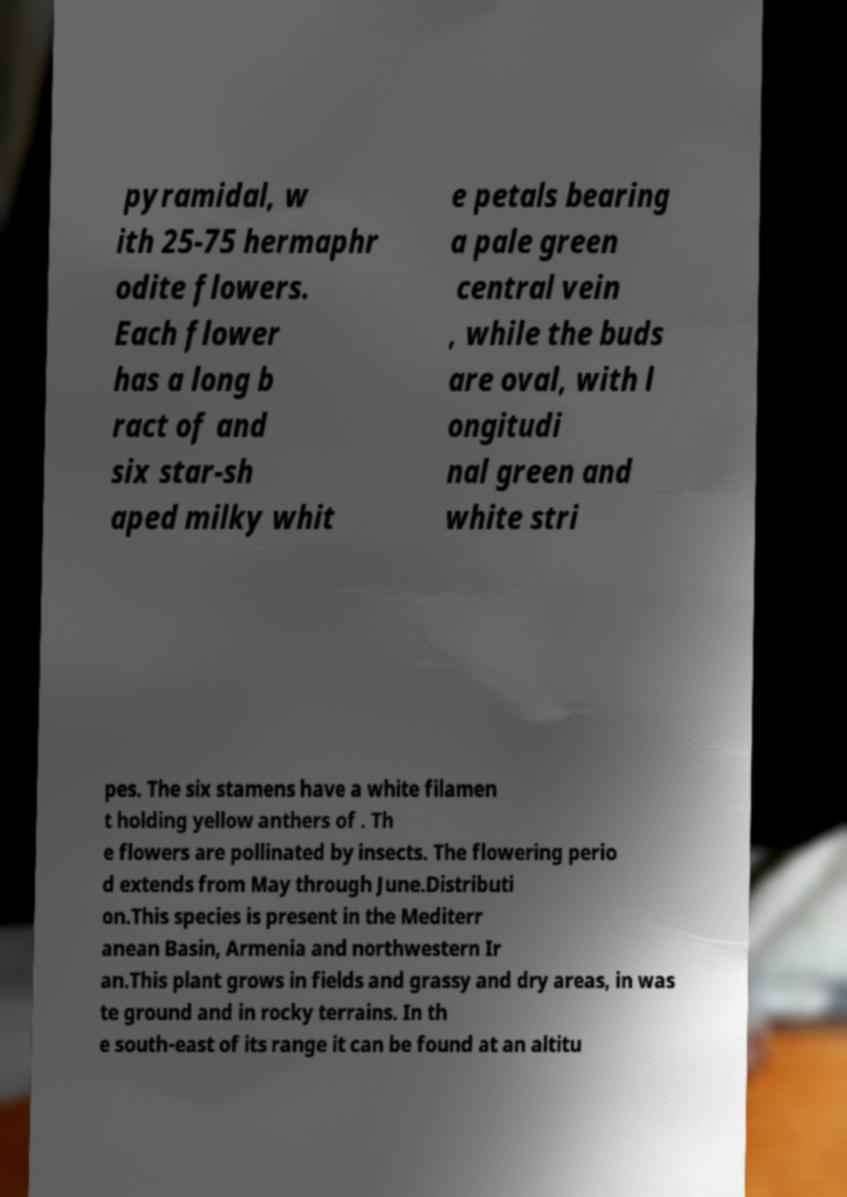For documentation purposes, I need the text within this image transcribed. Could you provide that? pyramidal, w ith 25-75 hermaphr odite flowers. Each flower has a long b ract of and six star-sh aped milky whit e petals bearing a pale green central vein , while the buds are oval, with l ongitudi nal green and white stri pes. The six stamens have a white filamen t holding yellow anthers of . Th e flowers are pollinated by insects. The flowering perio d extends from May through June.Distributi on.This species is present in the Mediterr anean Basin, Armenia and northwestern Ir an.This plant grows in fields and grassy and dry areas, in was te ground and in rocky terrains. In th e south-east of its range it can be found at an altitu 